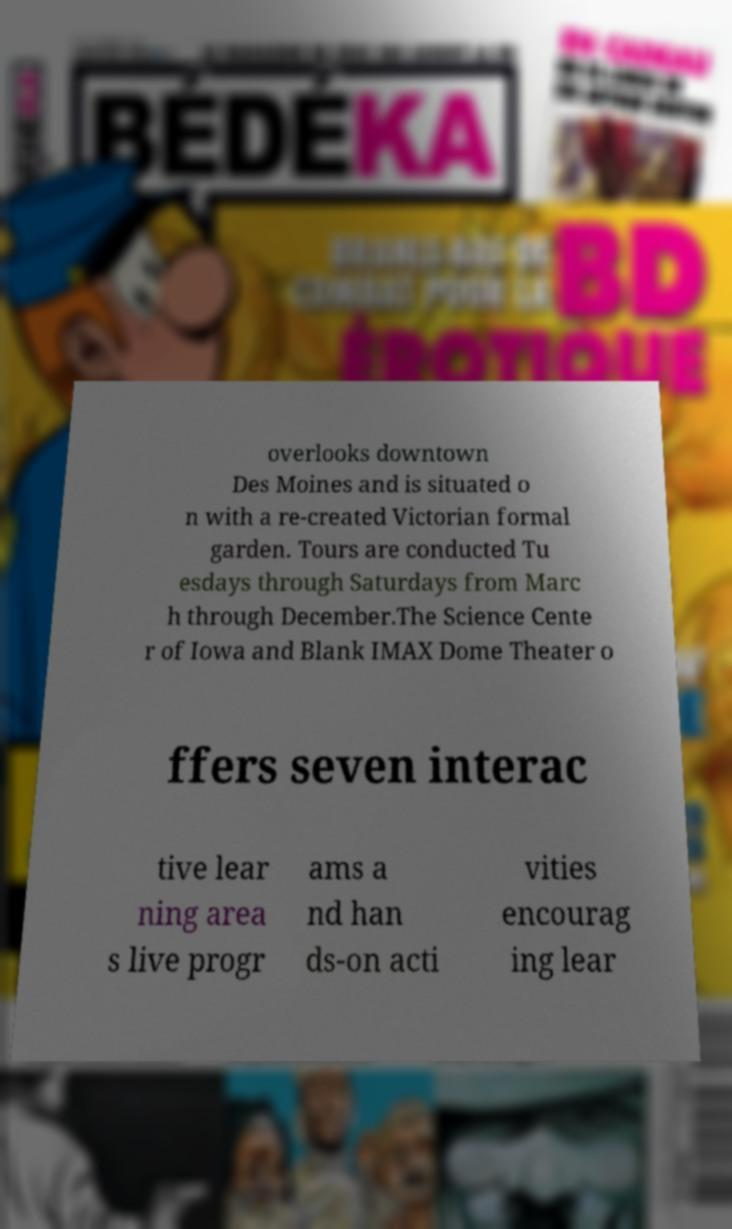Could you assist in decoding the text presented in this image and type it out clearly? overlooks downtown Des Moines and is situated o n with a re-created Victorian formal garden. Tours are conducted Tu esdays through Saturdays from Marc h through December.The Science Cente r of Iowa and Blank IMAX Dome Theater o ffers seven interac tive lear ning area s live progr ams a nd han ds-on acti vities encourag ing lear 